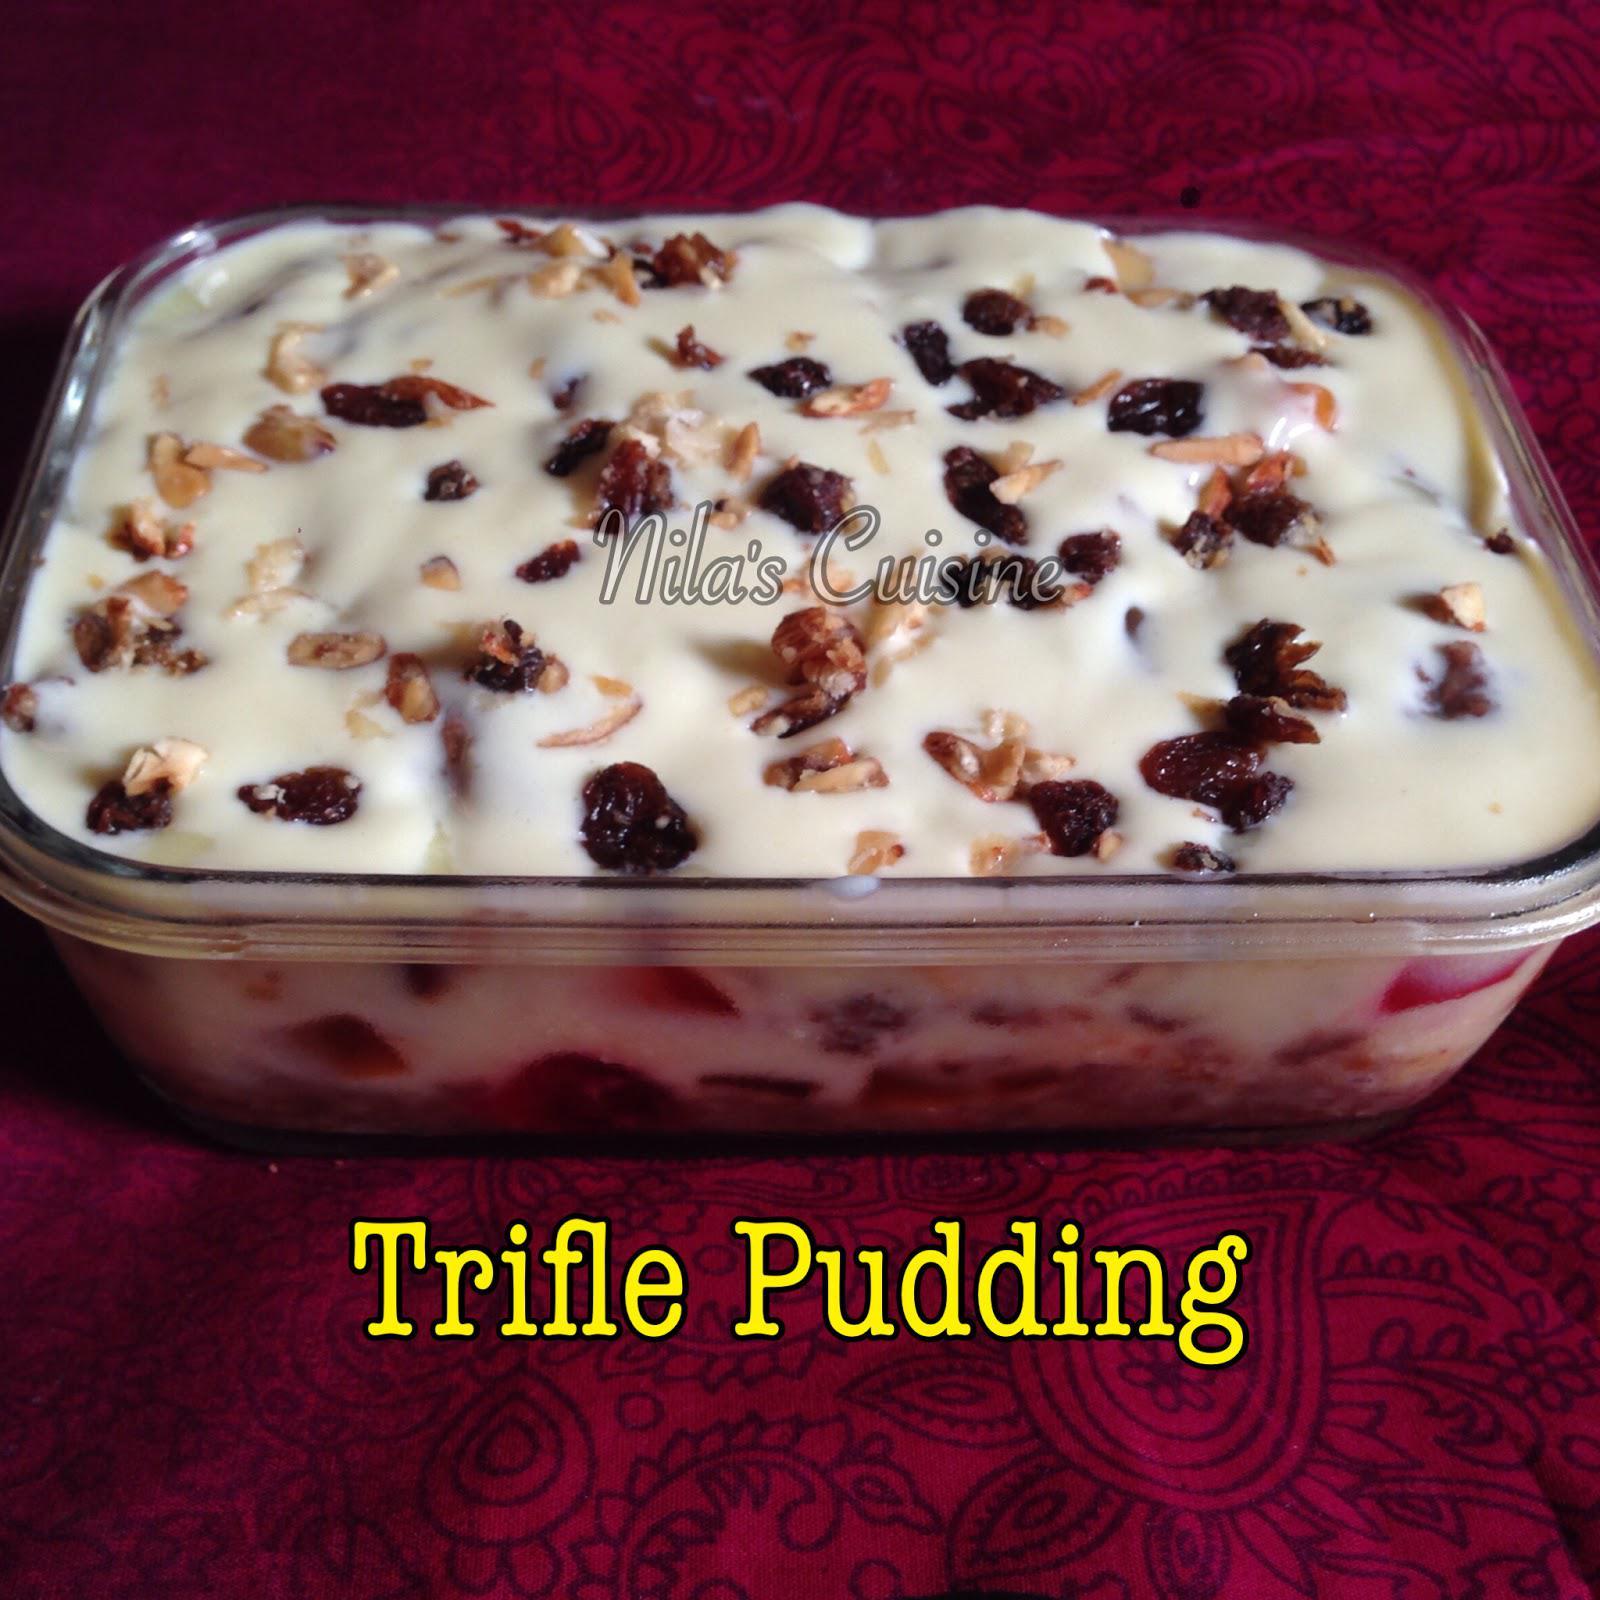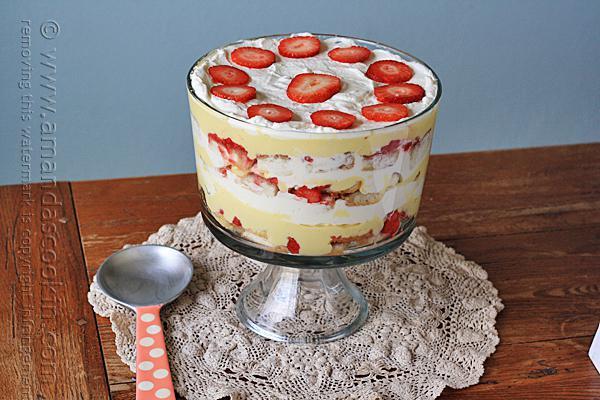The first image is the image on the left, the second image is the image on the right. Assess this claim about the two images: "A trifle is garnished with red fruit on white whipped cream.". Correct or not? Answer yes or no. Yes. 